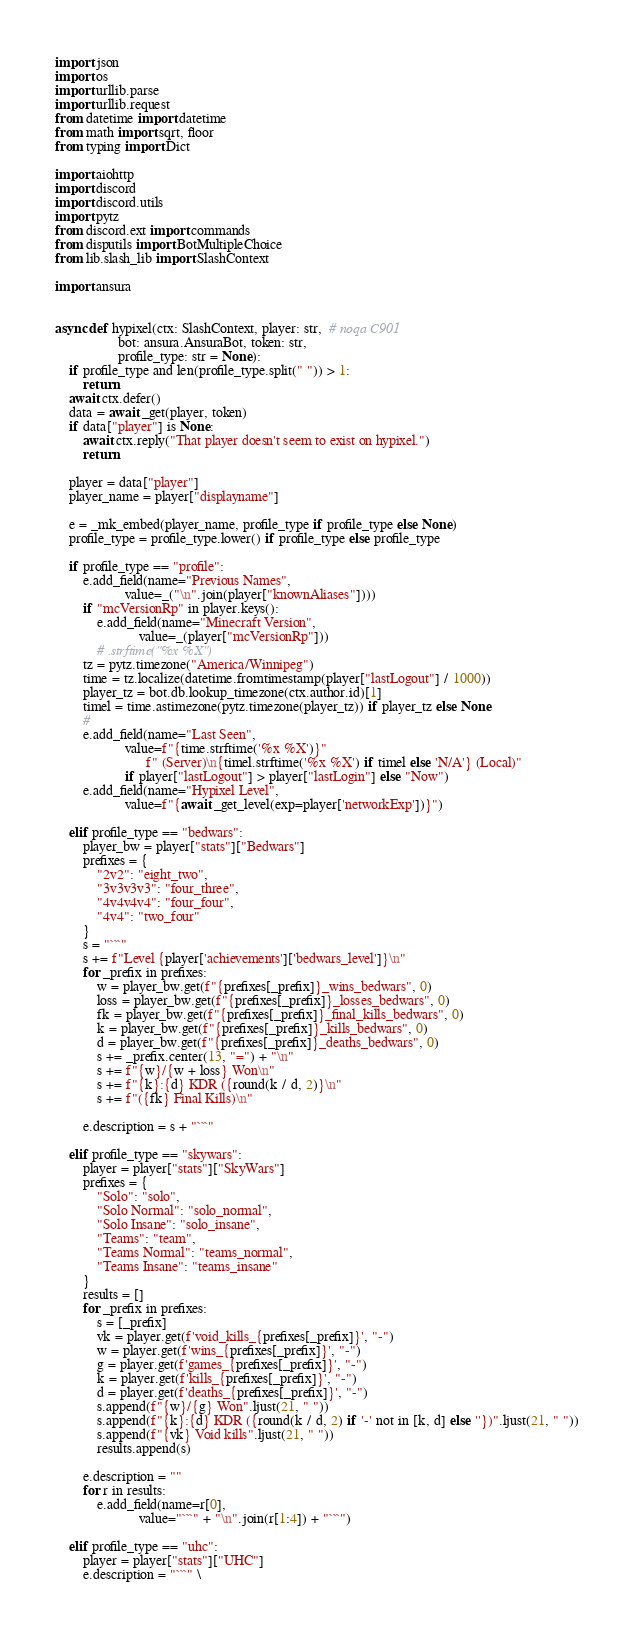<code> <loc_0><loc_0><loc_500><loc_500><_Python_>import json
import os
import urllib.parse
import urllib.request
from datetime import datetime
from math import sqrt, floor
from typing import Dict

import aiohttp
import discord
import discord.utils
import pytz
from discord.ext import commands
from disputils import BotMultipleChoice
from lib.slash_lib import SlashContext

import ansura


async def hypixel(ctx: SlashContext, player: str,  # noqa C901
                  bot: ansura.AnsuraBot, token: str,
                  profile_type: str = None):
    if profile_type and len(profile_type.split(" ")) > 1:
        return
    await ctx.defer()
    data = await _get(player, token)
    if data["player"] is None:
        await ctx.reply("That player doesn't seem to exist on hypixel.")
        return

    player = data["player"]
    player_name = player["displayname"]

    e = _mk_embed(player_name, profile_type if profile_type else None)
    profile_type = profile_type.lower() if profile_type else profile_type

    if profile_type == "profile":
        e.add_field(name="Previous Names",
                    value=_("\n".join(player["knownAliases"])))
        if "mcVersionRp" in player.keys():
            e.add_field(name="Minecraft Version",
                        value=_(player["mcVersionRp"]))
            # .strftime("%x %X")
        tz = pytz.timezone("America/Winnipeg")
        time = tz.localize(datetime.fromtimestamp(player["lastLogout"] / 1000))
        player_tz = bot.db.lookup_timezone(ctx.author.id)[1]
        timel = time.astimezone(pytz.timezone(player_tz)) if player_tz else None
        #
        e.add_field(name="Last Seen",
                    value=f"{time.strftime('%x %X')}"
                          f" (Server)\n{timel.strftime('%x %X') if timel else 'N/A'} (Local)"
                    if player["lastLogout"] > player["lastLogin"] else "Now")
        e.add_field(name="Hypixel Level",
                    value=f"{await _get_level(exp=player['networkExp'])}")

    elif profile_type == "bedwars":
        player_bw = player["stats"]["Bedwars"]
        prefixes = {
            "2v2": "eight_two",
            "3v3v3v3": "four_three",
            "4v4v4v4": "four_four",
            "4v4": "two_four"
        }
        s = "```"
        s += f"Level {player['achievements']['bedwars_level']}\n"
        for _prefix in prefixes:
            w = player_bw.get(f"{prefixes[_prefix]}_wins_bedwars", 0)
            loss = player_bw.get(f"{prefixes[_prefix]}_losses_bedwars", 0)
            fk = player_bw.get(f"{prefixes[_prefix]}_final_kills_bedwars", 0)
            k = player_bw.get(f"{prefixes[_prefix]}_kills_bedwars", 0)
            d = player_bw.get(f"{prefixes[_prefix]}_deaths_bedwars", 0)
            s += _prefix.center(13, "=") + "\n"
            s += f"{w}/{w + loss} Won\n"
            s += f"{k}:{d} KDR ({round(k / d, 2)}\n"
            s += f"({fk} Final Kills)\n"

        e.description = s + "```"

    elif profile_type == "skywars":
        player = player["stats"]["SkyWars"]
        prefixes = {
            "Solo": "solo",
            "Solo Normal": "solo_normal",
            "Solo Insane": "solo_insane",
            "Teams": "team",
            "Teams Normal": "teams_normal",
            "Teams Insane": "teams_insane"
        }
        results = []
        for _prefix in prefixes:
            s = [_prefix]
            vk = player.get(f'void_kills_{prefixes[_prefix]}', "-")
            w = player.get(f'wins_{prefixes[_prefix]}', "-")
            g = player.get(f'games_{prefixes[_prefix]}', "-")
            k = player.get(f'kills_{prefixes[_prefix]}', "-")
            d = player.get(f'deaths_{prefixes[_prefix]}', "-")
            s.append(f"{w}/{g} Won".ljust(21, " "))
            s.append(f"{k}:{d} KDR ({round(k / d, 2) if '-' not in [k, d] else ''})".ljust(21, " "))
            s.append(f"{vk} Void kills".ljust(21, " "))
            results.append(s)

        e.description = ""
        for r in results:
            e.add_field(name=r[0],
                        value="```" + "\n".join(r[1:4]) + "```")

    elif profile_type == "uhc":
        player = player["stats"]["UHC"]
        e.description = "```" \</code> 